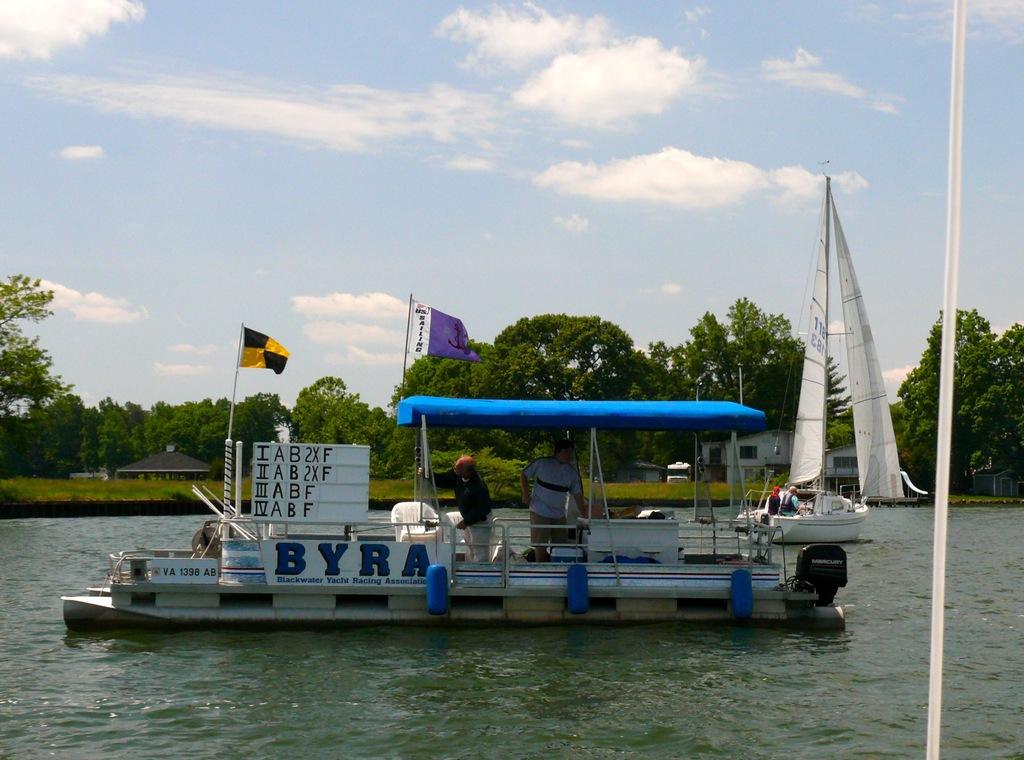What name is on the boat?
Ensure brevity in your answer.  Byra. 